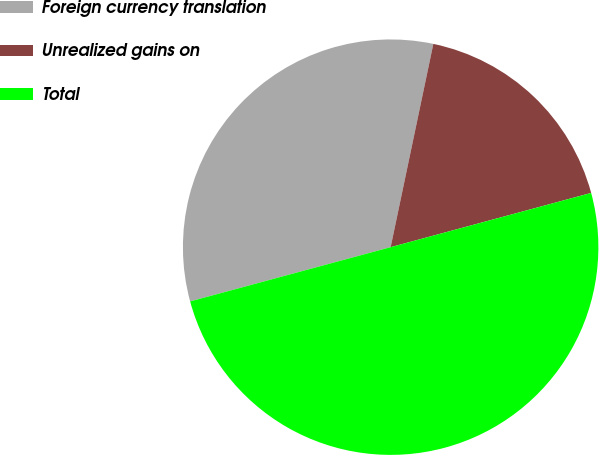<chart> <loc_0><loc_0><loc_500><loc_500><pie_chart><fcel>Foreign currency translation<fcel>Unrealized gains on<fcel>Total<nl><fcel>32.5%<fcel>17.5%<fcel>50.0%<nl></chart> 